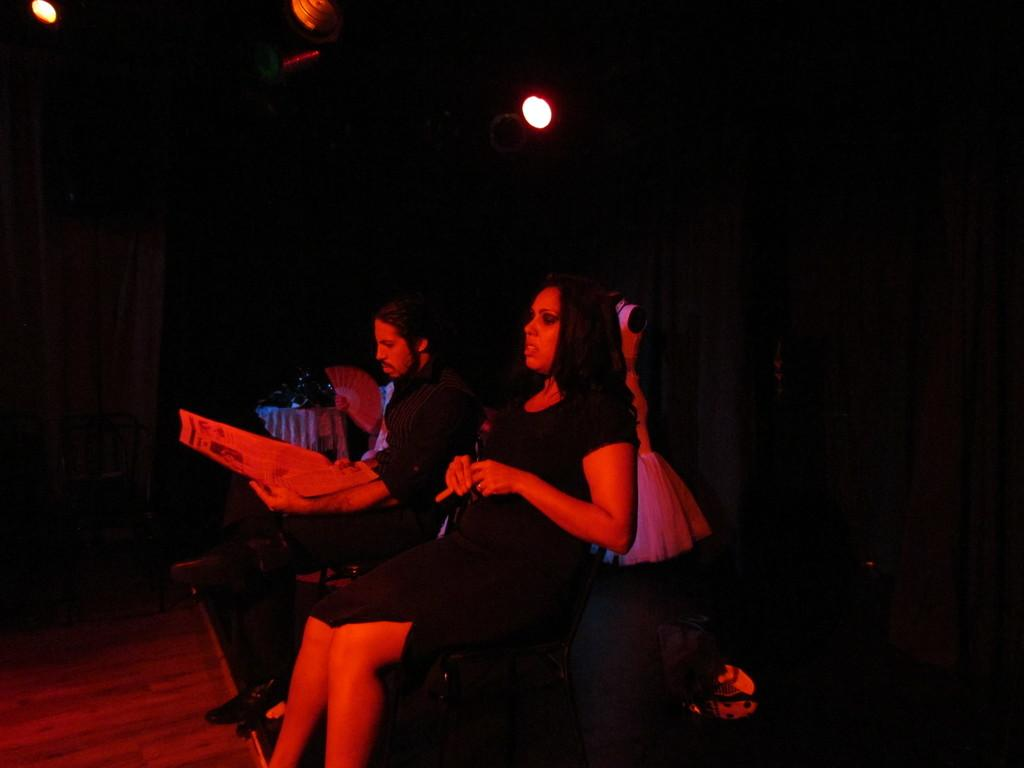How many people are in the image? There are two persons in the image. What are the two persons doing in the image? The two persons are playing an act. What can be observed about the background of the image? The background of the image is dark. How many snails can be seen crawling on the hook in the image? There are no snails or hooks present in the image. What news event is being discussed by the two persons in the image? The image does not depict a news event or any discussion about news. 